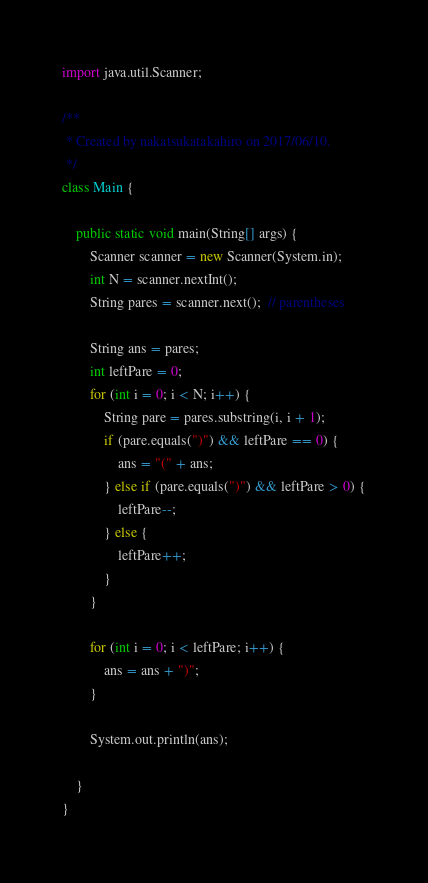<code> <loc_0><loc_0><loc_500><loc_500><_Java_>import java.util.Scanner;

/**
 * Created by nakatsukatakahiro on 2017/06/10.
 */
class Main {

    public static void main(String[] args) {
        Scanner scanner = new Scanner(System.in);
        int N = scanner.nextInt();
        String pares = scanner.next();  // parentheses

        String ans = pares;
        int leftPare = 0;
        for (int i = 0; i < N; i++) {
            String pare = pares.substring(i, i + 1);
            if (pare.equals(")") && leftPare == 0) {
                ans = "(" + ans;
            } else if (pare.equals(")") && leftPare > 0) {
                leftPare--;
            } else {
                leftPare++;
            }
        }

        for (int i = 0; i < leftPare; i++) {
            ans = ans + ")";
        }

        System.out.println(ans);

    }
}
</code> 